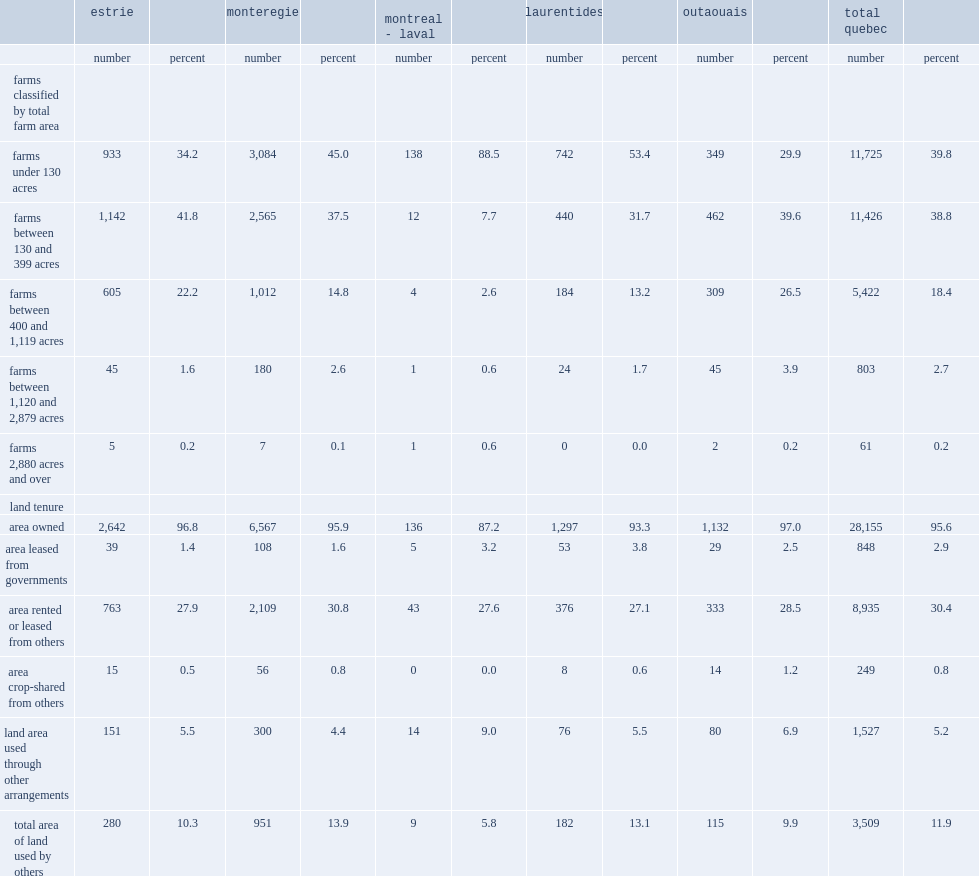List all the regions of quebec that had fewer small farms (less than 130 acres) and more medium-sized farms. Estrie outaouais. What is the most popluar type of land tenure in quebec? Area owned. 